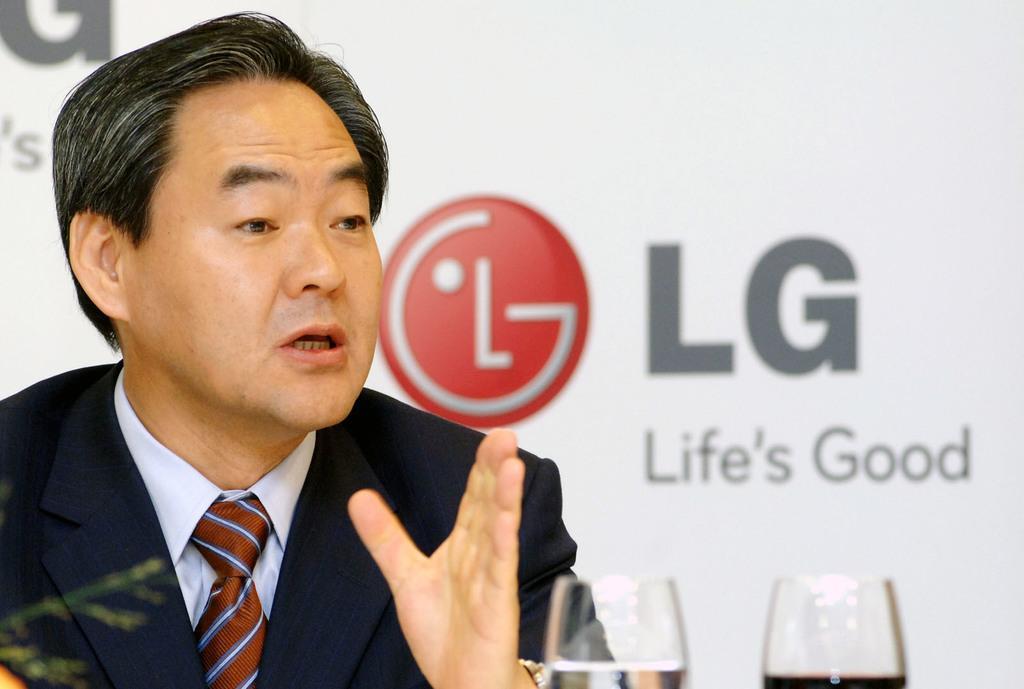Can you describe this image briefly? In the background we can see the hoarding and in this picture we can see a man wearing a blazer, shirt and a tie. It seems like he is talking. At the bottom we can see the glasses with liquids in them. 